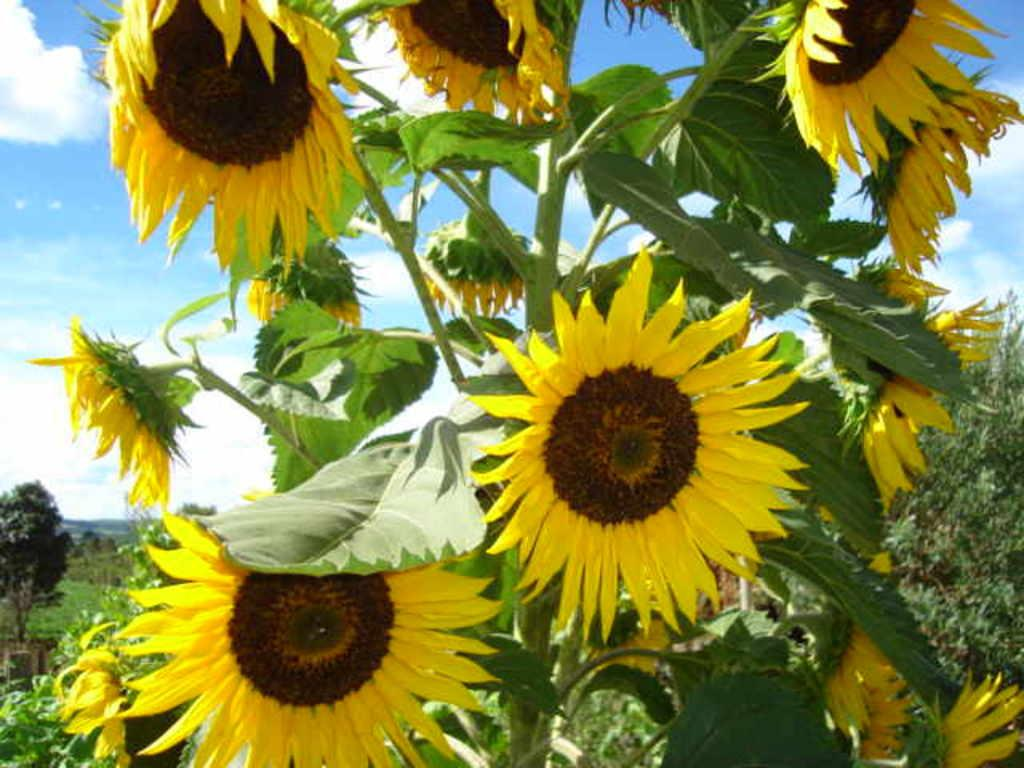What type of flowers are in the image? There are sunflowers in the image. What colors are the sunflowers? The sunflowers are in yellow and brown colors. What can be seen in the background of the image? There are trees and the sky visible in the background of the image. What is present in the sky? Clouds are present in the sky. Where is the cellar located in the image? There is no cellar present in the image. What type of work is being done in the image? The image does not depict any work being done. Is there an exchange happening in the image? There is no exchange happening in the image. 